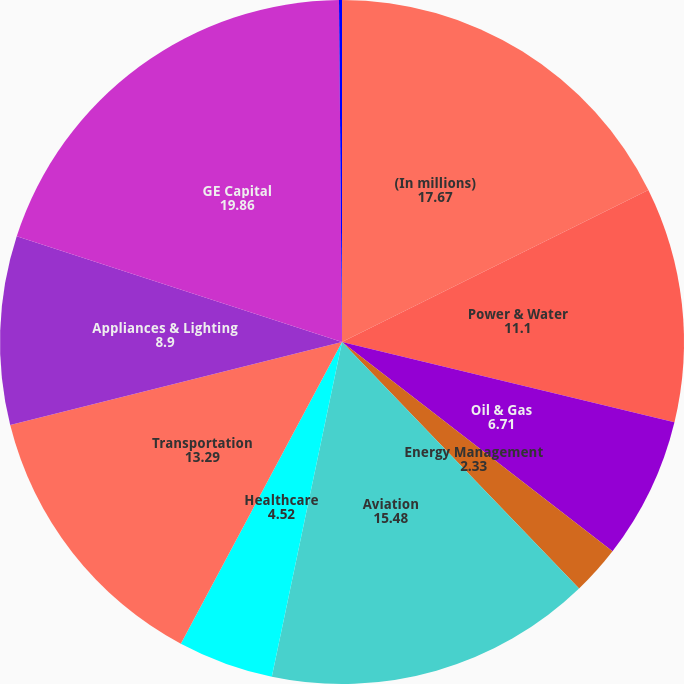<chart> <loc_0><loc_0><loc_500><loc_500><pie_chart><fcel>(In millions)<fcel>Power & Water<fcel>Oil & Gas<fcel>Energy Management<fcel>Aviation<fcel>Healthcare<fcel>Transportation<fcel>Appliances & Lighting<fcel>GE Capital<fcel>Corporate items and<nl><fcel>17.67%<fcel>11.1%<fcel>6.71%<fcel>2.33%<fcel>15.48%<fcel>4.52%<fcel>13.29%<fcel>8.9%<fcel>19.86%<fcel>0.14%<nl></chart> 